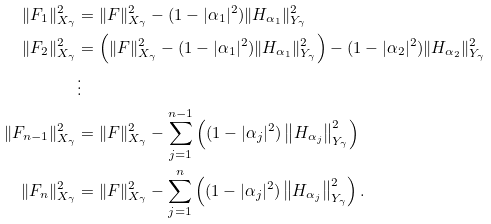<formula> <loc_0><loc_0><loc_500><loc_500>\| F _ { 1 } \| _ { X _ { \gamma } } ^ { 2 } & = \| F \| _ { X _ { \gamma } } ^ { 2 } - ( 1 - | \alpha _ { 1 } | ^ { 2 } ) \| H _ { \alpha _ { 1 } } \| _ { Y _ { \gamma } } ^ { 2 } \\ \| F _ { 2 } \| _ { X _ { \gamma } } ^ { 2 } & = \left ( \| F \| _ { X _ { \gamma } } ^ { 2 } - ( 1 - | \alpha _ { 1 } | ^ { 2 } ) \| H _ { \alpha _ { 1 } } \| _ { Y _ { \gamma } } ^ { 2 } \right ) - ( 1 - | \alpha _ { 2 } | ^ { 2 } ) \| H _ { \alpha _ { 2 } } \| _ { Y _ { \gamma } } ^ { 2 } \\ & \vdots \\ \| F _ { n - 1 } \| _ { X _ { \gamma } } ^ { 2 } & = \| F \| _ { X _ { \gamma } } ^ { 2 } - \sum _ { j = 1 } ^ { n - 1 } \left ( ( 1 - | \alpha _ { j } | ^ { 2 } ) \left \| H _ { \alpha _ { j } } \right \| _ { Y _ { \gamma } } ^ { 2 } \right ) \\ \| F _ { n } \| _ { X _ { \gamma } } ^ { 2 } & = \| F \| _ { X _ { \gamma } } ^ { 2 } - \sum _ { j = 1 } ^ { n } \left ( ( 1 - | \alpha _ { j } | ^ { 2 } ) \left \| H _ { \alpha _ { j } } \right \| _ { Y _ { \gamma } } ^ { 2 } \right ) .</formula> 